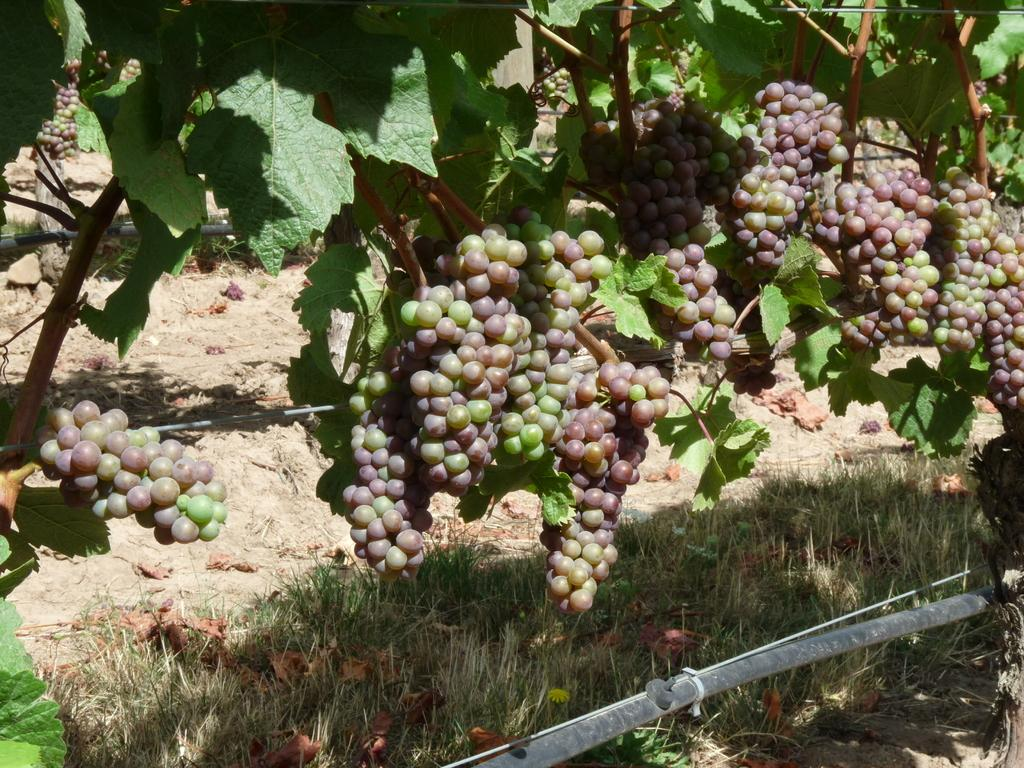What type of tree is in the image? There is a grape tree in the image. What can be found on the grape tree? There are grape fruits on the tree. What is the ground cover beneath the tree? There is grass below the tree. What type of acoustics can be heard from the grape tree in the image? There is no mention of any sounds or acoustics in the image, so it cannot be determined. 